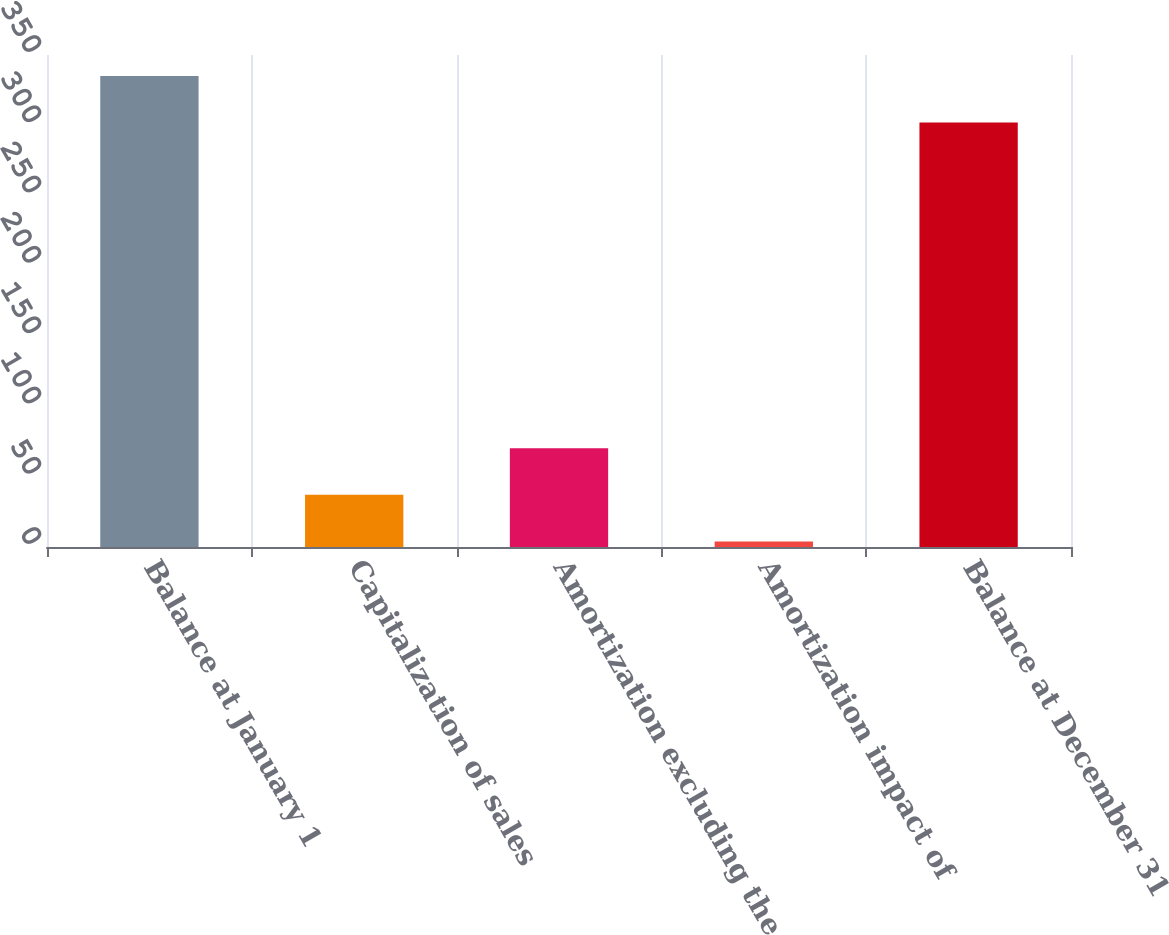Convert chart to OTSL. <chart><loc_0><loc_0><loc_500><loc_500><bar_chart><fcel>Balance at January 1<fcel>Capitalization of sales<fcel>Amortization excluding the<fcel>Amortization impact of<fcel>Balance at December 31<nl><fcel>335.1<fcel>37.1<fcel>70.2<fcel>4<fcel>302<nl></chart> 